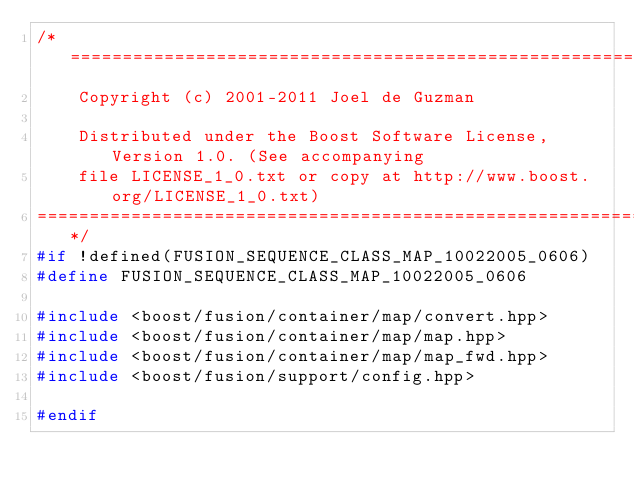<code> <loc_0><loc_0><loc_500><loc_500><_C++_>/*=============================================================================
    Copyright (c) 2001-2011 Joel de Guzman

    Distributed under the Boost Software License, Version 1.0. (See accompanying
    file LICENSE_1_0.txt or copy at http://www.boost.org/LICENSE_1_0.txt)
==============================================================================*/
#if !defined(FUSION_SEQUENCE_CLASS_MAP_10022005_0606)
#define FUSION_SEQUENCE_CLASS_MAP_10022005_0606

#include <boost/fusion/container/map/convert.hpp>
#include <boost/fusion/container/map/map.hpp>
#include <boost/fusion/container/map/map_fwd.hpp>
#include <boost/fusion/support/config.hpp>

#endif
</code> 